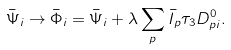<formula> <loc_0><loc_0><loc_500><loc_500>\bar { \Psi } _ { i } \to \bar { \Phi } _ { i } = \bar { \Psi } _ { i } + \lambda \sum _ { p } \bar { I } _ { p } \tau _ { 3 } D ^ { 0 } _ { p i } .</formula> 